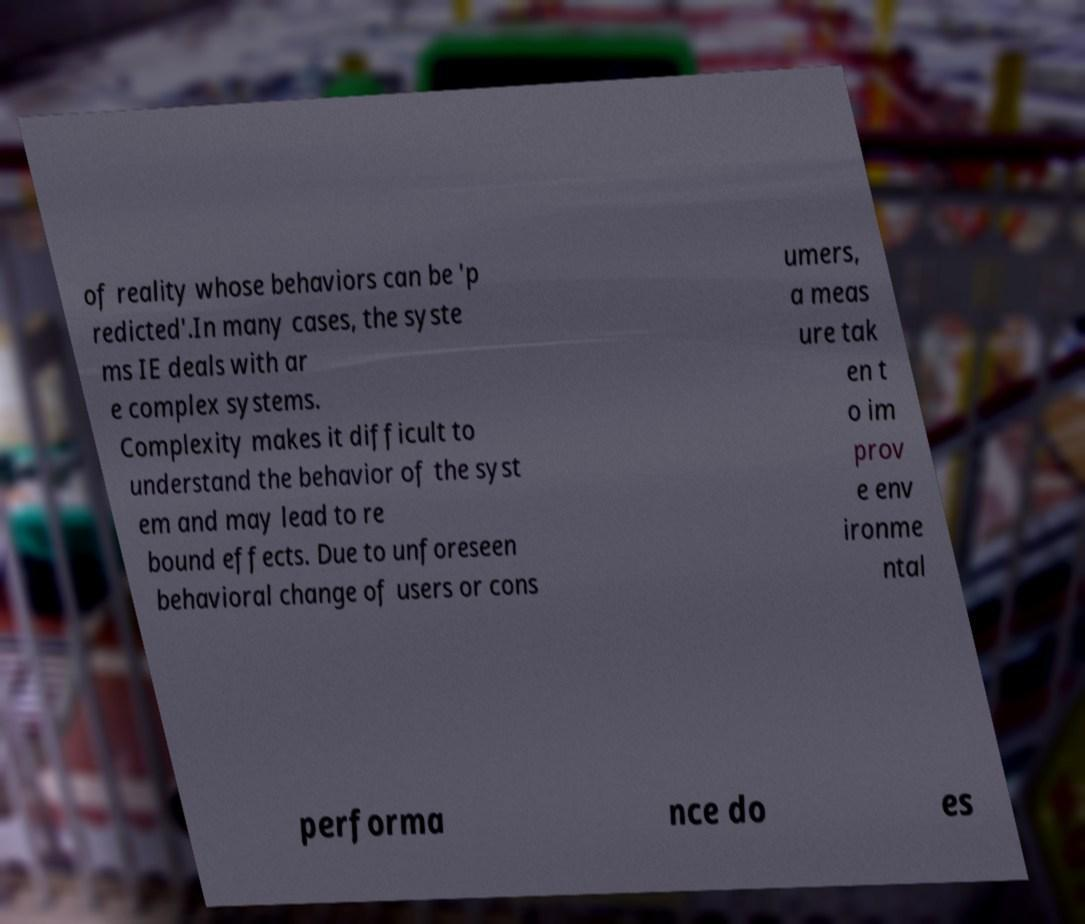Could you assist in decoding the text presented in this image and type it out clearly? of reality whose behaviors can be 'p redicted'.In many cases, the syste ms IE deals with ar e complex systems. Complexity makes it difficult to understand the behavior of the syst em and may lead to re bound effects. Due to unforeseen behavioral change of users or cons umers, a meas ure tak en t o im prov e env ironme ntal performa nce do es 